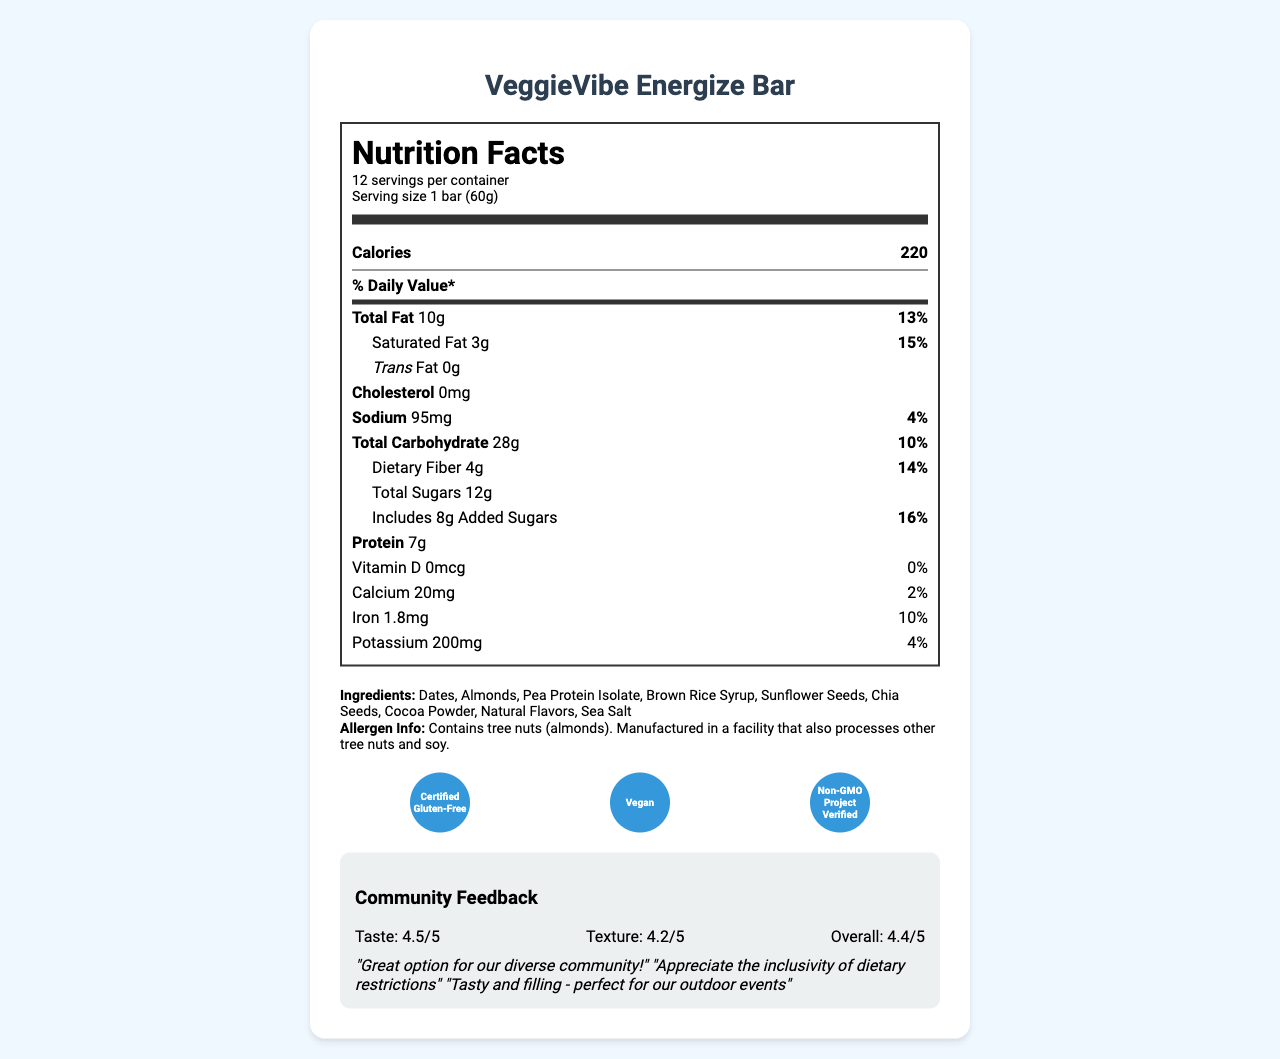How many servings per container are there? The label specifies that there are 12 servings per container.
Answer: 12 What is the serving size for the VeggieVibe Energize Bar? The serving size is stated as 1 bar (60g).
Answer: 1 bar (60g) How many grams of protein are in each VeggieVibe Energize Bar? The document specifies that each bar contains 7 grams of protein.
Answer: 7g What percentage of the daily value of saturated fat does each bar contain? The daily value percentage for saturated fat is listed as 15%.
Answer: 15% How much dietary fiber is in each serving? Each serving contains 4 grams of dietary fiber.
Answer: 4g Does the VeggieVibe Energize Bar contain any trans fat? The document indicates that the trans fat amount is 0g.
Answer: No Which of the following ingredients is not in the VeggieVibe Energize Bar? A. Dates B. Almonds C. Pea Protein Isolate D. Honey The ingredients list does not include honey, it includes Dates, Almonds, Pea Protein Isolate, and others.
Answer: D What is the total calorie count per serving? A. 180 B. 200 C. 220 D. 240 The bar contains 220 calories per serving as indicated in the document.
Answer: C Is the VeggieVibe Energize Bar suitable for people following a vegan diet? The document lists the bar as being certified vegan.
Answer: Yes Is there any cholesterol in the VeggieVibe Energize Bar? The document specifies that the cholesterol content is 0mg.
Answer: No Summarize the main certifications and dietary characteristics of the VeggieVibe Energize Bar. The document explicitly mentions the certifications and mentions the dietary inclusivity making it ideal for people with dietary restrictions.
Answer: The VeggieVibe Energize Bar is certified Gluten-Free, Vegan, and Non-GMO Project Verified. It is suitable for attendees with gluten sensitivities and vegan diets. Does the label provide information on Vitamin C content? The label shows details for various nutrients like Vitamin D, Calcium, Iron, and Potassium but does not mention Vitamin C.
Answer: Not enough information What is the community's overall satisfaction rating for the VeggieVibe Energize Bar? The community feedback section specifies an overall satisfaction rating of 4.4.
Answer: 4.4 What sustainability practice is mentioned regarding the packaging of the VeggieVibe Energize Bar? The document mentions that the wrapper is made from recycled materials and is fully recyclable.
Answer: The wrapper is made from 100% recycled materials and is recyclable. How much potassium does each bar contain? The label indicates that each bar contains 200mg of potassium.
Answer: 200mg What allergen is explicitly mentioned in the VeggieVibe Energize Bar? The allergen information specifies that the bar contains tree nuts (almonds).
Answer: Almonds 